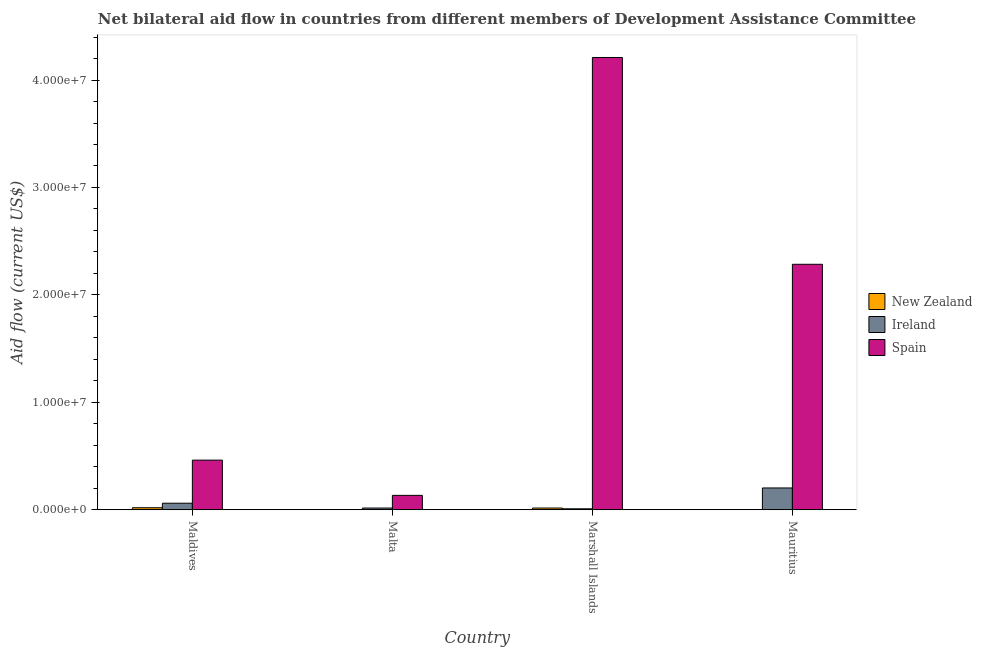How many bars are there on the 2nd tick from the left?
Your answer should be very brief. 3. How many bars are there on the 4th tick from the right?
Ensure brevity in your answer.  3. What is the label of the 1st group of bars from the left?
Your answer should be very brief. Maldives. In how many cases, is the number of bars for a given country not equal to the number of legend labels?
Keep it short and to the point. 0. What is the amount of aid provided by new zealand in Marshall Islands?
Provide a short and direct response. 1.60e+05. Across all countries, what is the maximum amount of aid provided by new zealand?
Provide a short and direct response. 1.90e+05. Across all countries, what is the minimum amount of aid provided by ireland?
Your answer should be very brief. 9.00e+04. In which country was the amount of aid provided by spain maximum?
Provide a succinct answer. Marshall Islands. In which country was the amount of aid provided by new zealand minimum?
Provide a succinct answer. Malta. What is the total amount of aid provided by ireland in the graph?
Offer a terse response. 2.89e+06. What is the difference between the amount of aid provided by new zealand in Malta and that in Mauritius?
Your response must be concise. -10000. What is the difference between the amount of aid provided by ireland in Marshall Islands and the amount of aid provided by spain in Maldives?
Your answer should be very brief. -4.53e+06. What is the average amount of aid provided by spain per country?
Your response must be concise. 1.77e+07. What is the difference between the amount of aid provided by spain and amount of aid provided by new zealand in Mauritius?
Give a very brief answer. 2.28e+07. In how many countries, is the amount of aid provided by ireland greater than 24000000 US$?
Offer a very short reply. 0. What is the ratio of the amount of aid provided by ireland in Maldives to that in Mauritius?
Your response must be concise. 0.3. Is the amount of aid provided by new zealand in Maldives less than that in Mauritius?
Keep it short and to the point. No. What is the difference between the highest and the lowest amount of aid provided by new zealand?
Give a very brief answer. 1.80e+05. In how many countries, is the amount of aid provided by ireland greater than the average amount of aid provided by ireland taken over all countries?
Offer a terse response. 1. What does the 2nd bar from the left in Malta represents?
Provide a succinct answer. Ireland. What does the 3rd bar from the right in Malta represents?
Your answer should be compact. New Zealand. Is it the case that in every country, the sum of the amount of aid provided by new zealand and amount of aid provided by ireland is greater than the amount of aid provided by spain?
Give a very brief answer. No. Are all the bars in the graph horizontal?
Offer a terse response. No. How many countries are there in the graph?
Ensure brevity in your answer.  4. Are the values on the major ticks of Y-axis written in scientific E-notation?
Keep it short and to the point. Yes. Does the graph contain any zero values?
Provide a short and direct response. No. Where does the legend appear in the graph?
Give a very brief answer. Center right. How many legend labels are there?
Give a very brief answer. 3. What is the title of the graph?
Ensure brevity in your answer.  Net bilateral aid flow in countries from different members of Development Assistance Committee. Does "Infant(female)" appear as one of the legend labels in the graph?
Your response must be concise. No. What is the label or title of the X-axis?
Provide a succinct answer. Country. What is the Aid flow (current US$) in Ireland in Maldives?
Provide a succinct answer. 6.10e+05. What is the Aid flow (current US$) of Spain in Maldives?
Provide a succinct answer. 4.62e+06. What is the Aid flow (current US$) in New Zealand in Malta?
Your response must be concise. 10000. What is the Aid flow (current US$) of Ireland in Malta?
Offer a very short reply. 1.60e+05. What is the Aid flow (current US$) in Spain in Malta?
Your answer should be compact. 1.34e+06. What is the Aid flow (current US$) of Ireland in Marshall Islands?
Make the answer very short. 9.00e+04. What is the Aid flow (current US$) of Spain in Marshall Islands?
Offer a terse response. 4.21e+07. What is the Aid flow (current US$) of Ireland in Mauritius?
Your answer should be very brief. 2.03e+06. What is the Aid flow (current US$) in Spain in Mauritius?
Keep it short and to the point. 2.28e+07. Across all countries, what is the maximum Aid flow (current US$) in New Zealand?
Make the answer very short. 1.90e+05. Across all countries, what is the maximum Aid flow (current US$) of Ireland?
Provide a short and direct response. 2.03e+06. Across all countries, what is the maximum Aid flow (current US$) in Spain?
Ensure brevity in your answer.  4.21e+07. Across all countries, what is the minimum Aid flow (current US$) in New Zealand?
Provide a succinct answer. 10000. Across all countries, what is the minimum Aid flow (current US$) in Spain?
Offer a very short reply. 1.34e+06. What is the total Aid flow (current US$) in Ireland in the graph?
Ensure brevity in your answer.  2.89e+06. What is the total Aid flow (current US$) of Spain in the graph?
Your answer should be very brief. 7.09e+07. What is the difference between the Aid flow (current US$) of Ireland in Maldives and that in Malta?
Make the answer very short. 4.50e+05. What is the difference between the Aid flow (current US$) in Spain in Maldives and that in Malta?
Ensure brevity in your answer.  3.28e+06. What is the difference between the Aid flow (current US$) of New Zealand in Maldives and that in Marshall Islands?
Your answer should be very brief. 3.00e+04. What is the difference between the Aid flow (current US$) in Ireland in Maldives and that in Marshall Islands?
Offer a terse response. 5.20e+05. What is the difference between the Aid flow (current US$) of Spain in Maldives and that in Marshall Islands?
Provide a short and direct response. -3.75e+07. What is the difference between the Aid flow (current US$) in New Zealand in Maldives and that in Mauritius?
Offer a terse response. 1.70e+05. What is the difference between the Aid flow (current US$) of Ireland in Maldives and that in Mauritius?
Your response must be concise. -1.42e+06. What is the difference between the Aid flow (current US$) of Spain in Maldives and that in Mauritius?
Give a very brief answer. -1.82e+07. What is the difference between the Aid flow (current US$) in Spain in Malta and that in Marshall Islands?
Give a very brief answer. -4.08e+07. What is the difference between the Aid flow (current US$) of Ireland in Malta and that in Mauritius?
Offer a very short reply. -1.87e+06. What is the difference between the Aid flow (current US$) in Spain in Malta and that in Mauritius?
Offer a terse response. -2.15e+07. What is the difference between the Aid flow (current US$) in New Zealand in Marshall Islands and that in Mauritius?
Provide a short and direct response. 1.40e+05. What is the difference between the Aid flow (current US$) of Ireland in Marshall Islands and that in Mauritius?
Offer a very short reply. -1.94e+06. What is the difference between the Aid flow (current US$) in Spain in Marshall Islands and that in Mauritius?
Your response must be concise. 1.92e+07. What is the difference between the Aid flow (current US$) in New Zealand in Maldives and the Aid flow (current US$) in Ireland in Malta?
Your answer should be compact. 3.00e+04. What is the difference between the Aid flow (current US$) of New Zealand in Maldives and the Aid flow (current US$) of Spain in Malta?
Your answer should be compact. -1.15e+06. What is the difference between the Aid flow (current US$) in Ireland in Maldives and the Aid flow (current US$) in Spain in Malta?
Your response must be concise. -7.30e+05. What is the difference between the Aid flow (current US$) of New Zealand in Maldives and the Aid flow (current US$) of Ireland in Marshall Islands?
Your answer should be very brief. 1.00e+05. What is the difference between the Aid flow (current US$) in New Zealand in Maldives and the Aid flow (current US$) in Spain in Marshall Islands?
Your answer should be compact. -4.19e+07. What is the difference between the Aid flow (current US$) in Ireland in Maldives and the Aid flow (current US$) in Spain in Marshall Islands?
Offer a terse response. -4.15e+07. What is the difference between the Aid flow (current US$) in New Zealand in Maldives and the Aid flow (current US$) in Ireland in Mauritius?
Provide a short and direct response. -1.84e+06. What is the difference between the Aid flow (current US$) in New Zealand in Maldives and the Aid flow (current US$) in Spain in Mauritius?
Your answer should be very brief. -2.27e+07. What is the difference between the Aid flow (current US$) in Ireland in Maldives and the Aid flow (current US$) in Spain in Mauritius?
Make the answer very short. -2.22e+07. What is the difference between the Aid flow (current US$) of New Zealand in Malta and the Aid flow (current US$) of Spain in Marshall Islands?
Your answer should be compact. -4.21e+07. What is the difference between the Aid flow (current US$) of Ireland in Malta and the Aid flow (current US$) of Spain in Marshall Islands?
Your answer should be compact. -4.19e+07. What is the difference between the Aid flow (current US$) of New Zealand in Malta and the Aid flow (current US$) of Ireland in Mauritius?
Your answer should be compact. -2.02e+06. What is the difference between the Aid flow (current US$) in New Zealand in Malta and the Aid flow (current US$) in Spain in Mauritius?
Provide a short and direct response. -2.28e+07. What is the difference between the Aid flow (current US$) of Ireland in Malta and the Aid flow (current US$) of Spain in Mauritius?
Your answer should be compact. -2.27e+07. What is the difference between the Aid flow (current US$) of New Zealand in Marshall Islands and the Aid flow (current US$) of Ireland in Mauritius?
Your answer should be very brief. -1.87e+06. What is the difference between the Aid flow (current US$) of New Zealand in Marshall Islands and the Aid flow (current US$) of Spain in Mauritius?
Keep it short and to the point. -2.27e+07. What is the difference between the Aid flow (current US$) in Ireland in Marshall Islands and the Aid flow (current US$) in Spain in Mauritius?
Offer a very short reply. -2.28e+07. What is the average Aid flow (current US$) of New Zealand per country?
Ensure brevity in your answer.  9.50e+04. What is the average Aid flow (current US$) in Ireland per country?
Offer a very short reply. 7.22e+05. What is the average Aid flow (current US$) of Spain per country?
Provide a short and direct response. 1.77e+07. What is the difference between the Aid flow (current US$) in New Zealand and Aid flow (current US$) in Ireland in Maldives?
Your answer should be very brief. -4.20e+05. What is the difference between the Aid flow (current US$) in New Zealand and Aid flow (current US$) in Spain in Maldives?
Offer a very short reply. -4.43e+06. What is the difference between the Aid flow (current US$) of Ireland and Aid flow (current US$) of Spain in Maldives?
Offer a very short reply. -4.01e+06. What is the difference between the Aid flow (current US$) in New Zealand and Aid flow (current US$) in Spain in Malta?
Keep it short and to the point. -1.33e+06. What is the difference between the Aid flow (current US$) in Ireland and Aid flow (current US$) in Spain in Malta?
Your answer should be very brief. -1.18e+06. What is the difference between the Aid flow (current US$) of New Zealand and Aid flow (current US$) of Ireland in Marshall Islands?
Your answer should be very brief. 7.00e+04. What is the difference between the Aid flow (current US$) of New Zealand and Aid flow (current US$) of Spain in Marshall Islands?
Your answer should be very brief. -4.19e+07. What is the difference between the Aid flow (current US$) of Ireland and Aid flow (current US$) of Spain in Marshall Islands?
Offer a very short reply. -4.20e+07. What is the difference between the Aid flow (current US$) of New Zealand and Aid flow (current US$) of Ireland in Mauritius?
Offer a terse response. -2.01e+06. What is the difference between the Aid flow (current US$) in New Zealand and Aid flow (current US$) in Spain in Mauritius?
Make the answer very short. -2.28e+07. What is the difference between the Aid flow (current US$) in Ireland and Aid flow (current US$) in Spain in Mauritius?
Your response must be concise. -2.08e+07. What is the ratio of the Aid flow (current US$) of Ireland in Maldives to that in Malta?
Your answer should be compact. 3.81. What is the ratio of the Aid flow (current US$) in Spain in Maldives to that in Malta?
Ensure brevity in your answer.  3.45. What is the ratio of the Aid flow (current US$) of New Zealand in Maldives to that in Marshall Islands?
Ensure brevity in your answer.  1.19. What is the ratio of the Aid flow (current US$) of Ireland in Maldives to that in Marshall Islands?
Your response must be concise. 6.78. What is the ratio of the Aid flow (current US$) in Spain in Maldives to that in Marshall Islands?
Provide a short and direct response. 0.11. What is the ratio of the Aid flow (current US$) of Ireland in Maldives to that in Mauritius?
Ensure brevity in your answer.  0.3. What is the ratio of the Aid flow (current US$) in Spain in Maldives to that in Mauritius?
Ensure brevity in your answer.  0.2. What is the ratio of the Aid flow (current US$) of New Zealand in Malta to that in Marshall Islands?
Your answer should be compact. 0.06. What is the ratio of the Aid flow (current US$) of Ireland in Malta to that in Marshall Islands?
Make the answer very short. 1.78. What is the ratio of the Aid flow (current US$) in Spain in Malta to that in Marshall Islands?
Ensure brevity in your answer.  0.03. What is the ratio of the Aid flow (current US$) in New Zealand in Malta to that in Mauritius?
Offer a very short reply. 0.5. What is the ratio of the Aid flow (current US$) of Ireland in Malta to that in Mauritius?
Your answer should be compact. 0.08. What is the ratio of the Aid flow (current US$) of Spain in Malta to that in Mauritius?
Your answer should be very brief. 0.06. What is the ratio of the Aid flow (current US$) of New Zealand in Marshall Islands to that in Mauritius?
Provide a succinct answer. 8. What is the ratio of the Aid flow (current US$) in Ireland in Marshall Islands to that in Mauritius?
Keep it short and to the point. 0.04. What is the ratio of the Aid flow (current US$) of Spain in Marshall Islands to that in Mauritius?
Provide a short and direct response. 1.84. What is the difference between the highest and the second highest Aid flow (current US$) of New Zealand?
Your answer should be compact. 3.00e+04. What is the difference between the highest and the second highest Aid flow (current US$) in Ireland?
Give a very brief answer. 1.42e+06. What is the difference between the highest and the second highest Aid flow (current US$) in Spain?
Keep it short and to the point. 1.92e+07. What is the difference between the highest and the lowest Aid flow (current US$) in Ireland?
Give a very brief answer. 1.94e+06. What is the difference between the highest and the lowest Aid flow (current US$) in Spain?
Give a very brief answer. 4.08e+07. 